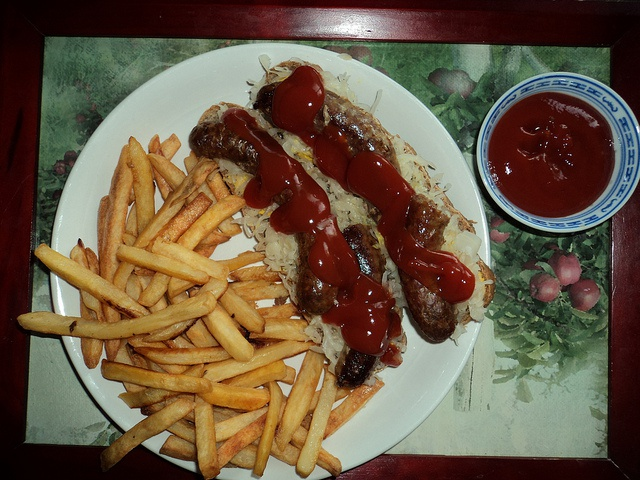Describe the objects in this image and their specific colors. I can see bowl in black, maroon, darkgray, and gray tones, hot dog in black, maroon, and gray tones, and hot dog in black, maroon, and tan tones in this image. 